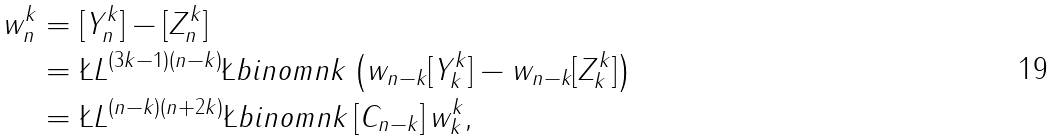<formula> <loc_0><loc_0><loc_500><loc_500>w ^ { k } _ { n } & = [ Y _ { n } ^ { k } ] - [ Z ^ { k } _ { n } ] \\ & = \L L ^ { ( 3 k - 1 ) ( n - k ) } \L b i n o m { n } { k } \left ( w _ { n - k } [ Y ^ { k } _ { k } ] - w _ { n - k } [ Z ^ { k } _ { k } ] \right ) \\ & = \L L ^ { ( n - k ) ( n + 2 k ) } \L b i n o m { n } { k } \, [ C _ { n - k } ] \, w ^ { k } _ { k } ,</formula> 